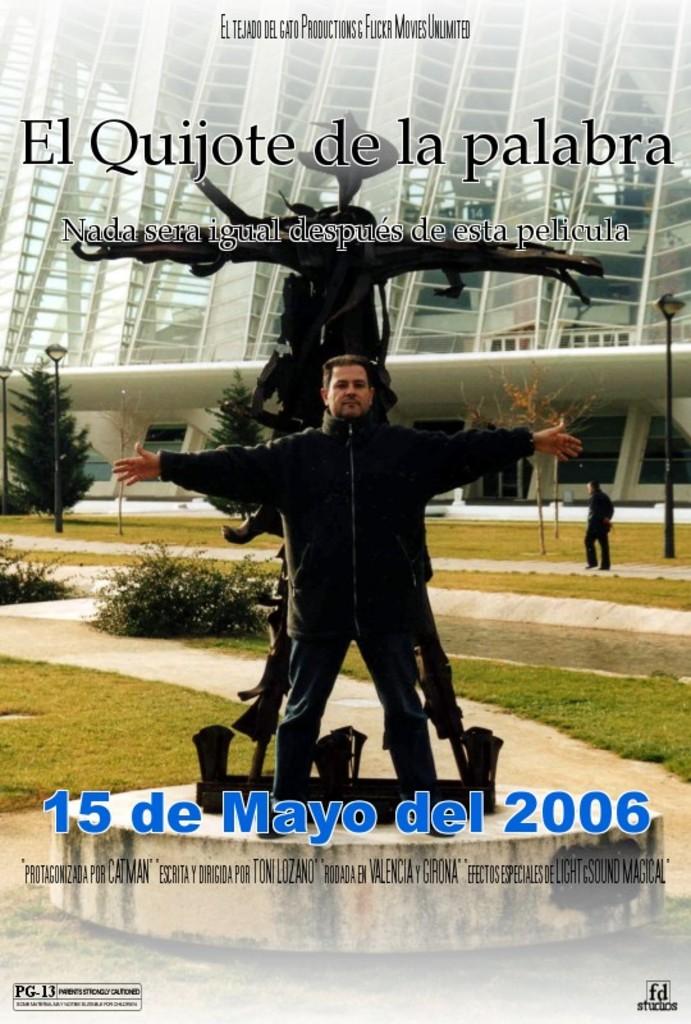What year on the 15th of mayo is displayed?
Your answer should be compact. 2006. What is the title?
Offer a very short reply. El quijote de la palabra. 